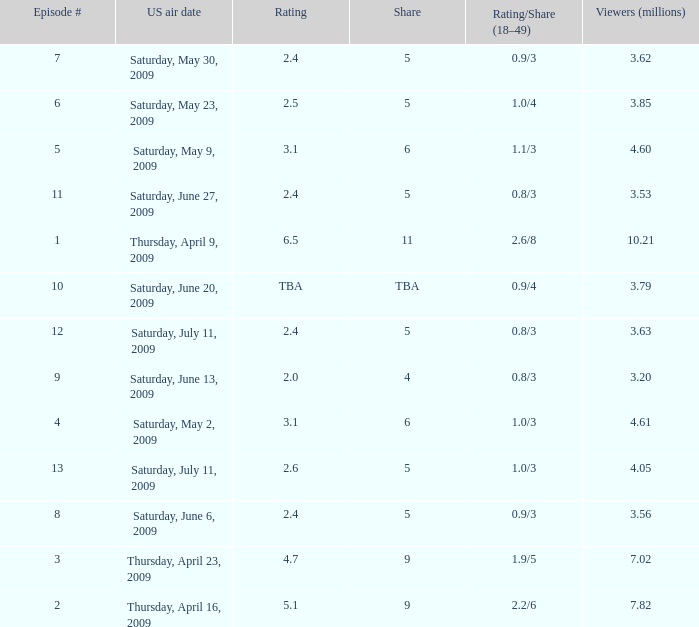What is the average number of million viewers that watched an episode before episode 11 with a share of 4? 3.2. 